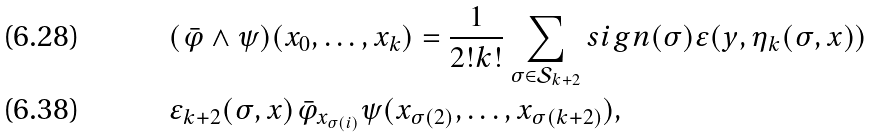<formula> <loc_0><loc_0><loc_500><loc_500>& ( \bar { \varphi } \wedge \psi ) ( x _ { 0 } , \dots , x _ { k } ) = \frac { 1 } { 2 ! k ! } \sum _ { \sigma \in \mathcal { S } _ { k + 2 } } s i g n ( \sigma ) \varepsilon ( y , \eta _ { k } ( \sigma , x ) ) \\ & \varepsilon _ { k + 2 } ( \sigma , x ) \bar { \varphi } _ { x _ { \sigma ( i ) } } \psi ( x _ { \sigma ( 2 ) } , \dots , x _ { \sigma ( k + 2 ) } ) ,</formula> 